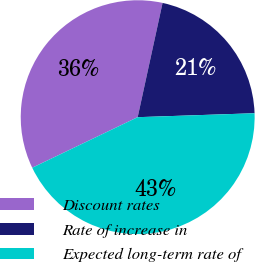Convert chart to OTSL. <chart><loc_0><loc_0><loc_500><loc_500><pie_chart><fcel>Discount rates<fcel>Rate of increase in<fcel>Expected long-term rate of<nl><fcel>35.53%<fcel>21.05%<fcel>43.42%<nl></chart> 